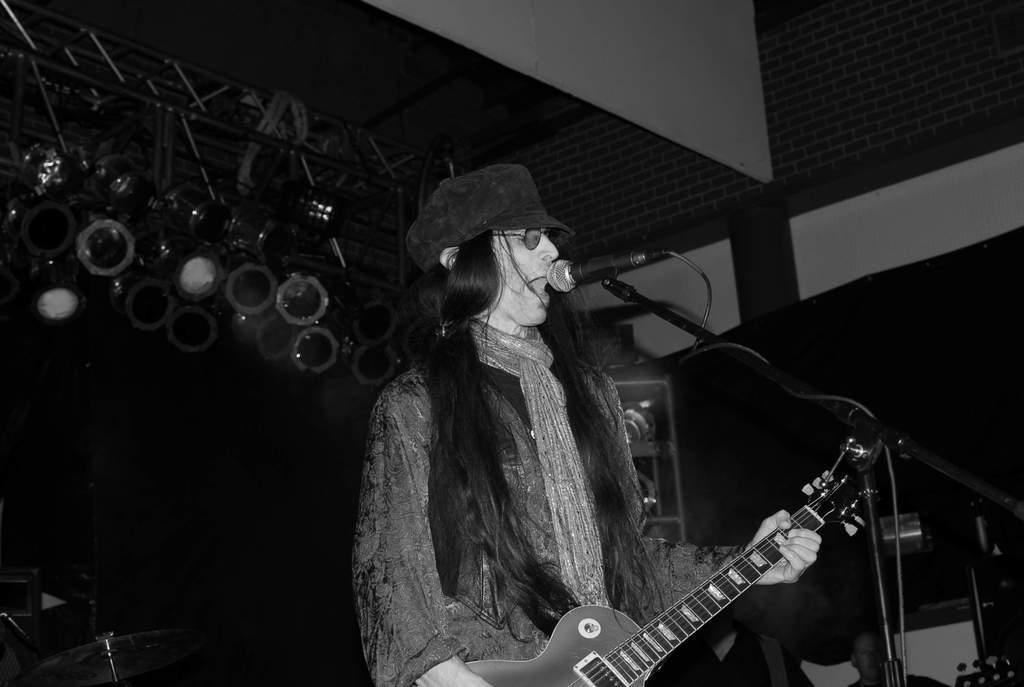In one or two sentences, can you explain what this image depicts? In the picture we can see a person standing near the micro phone and holding a guitar, the person is having a long hairs with black cap, in the background we can see some lights to the stand and some musical instruments on the floor. 